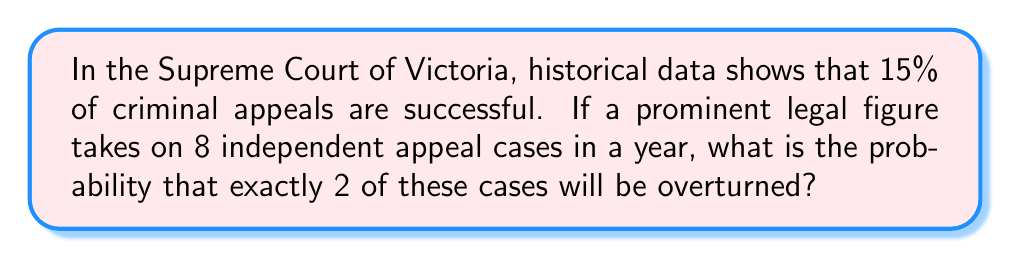Help me with this question. To solve this problem, we can use the binomial probability distribution, as we have a fixed number of independent trials (appeal cases) with two possible outcomes (overturned or not overturned) and a constant probability of success.

Let's define our variables:
$n = 8$ (number of appeal cases)
$k = 2$ (number of successful appeals we're interested in)
$p = 0.15$ (probability of a successful appeal)

The binomial probability formula is:

$$P(X = k) = \binom{n}{k} p^k (1-p)^{n-k}$$

Where $\binom{n}{k}$ is the binomial coefficient, calculated as:

$$\binom{n}{k} = \frac{n!}{k!(n-k)!}$$

Step 1: Calculate the binomial coefficient
$$\binom{8}{2} = \frac{8!}{2!(8-2)!} = \frac{8!}{2!6!} = 28$$

Step 2: Apply the binomial probability formula
$$P(X = 2) = 28 \cdot (0.15)^2 \cdot (1-0.15)^{8-2}$$
$$= 28 \cdot (0.15)^2 \cdot (0.85)^6$$
$$= 28 \cdot 0.0225 \cdot 0.3771$$
$$= 0.2385$$

Step 3: Convert to percentage
$0.2385 \cdot 100\% = 23.85\%$

Therefore, the probability of exactly 2 out of 8 appeal cases being overturned is approximately 23.85%.
Answer: 23.85% 